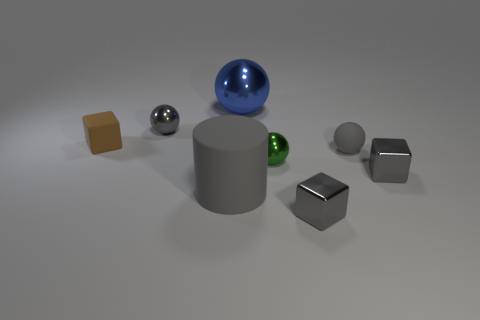Can you describe the positioning of the geometric objects relative to each other? Certainly! At the center, there is a large gray cylinder. To its right, a blue glossy sphere is visible, and to its left, a smaller, reflective metallic sphere rests. In front of the cylinder, a green glossy sphere and a gray matte ball are positioned close to each other, while a brown cube sits in the foreground to the left, slightly apart from the other objects. Behind the cylinder, there are two cubes - the closest to the cylinder has a metallic reflectivity, and the furthest one has a matte beige finish. 